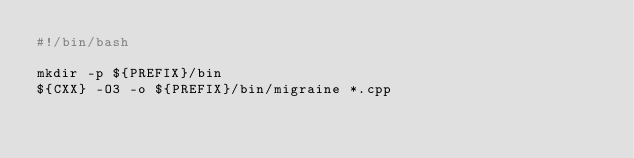Convert code to text. <code><loc_0><loc_0><loc_500><loc_500><_Bash_>#!/bin/bash

mkdir -p ${PREFIX}/bin
${CXX} -O3 -o ${PREFIX}/bin/migraine *.cpp
</code> 